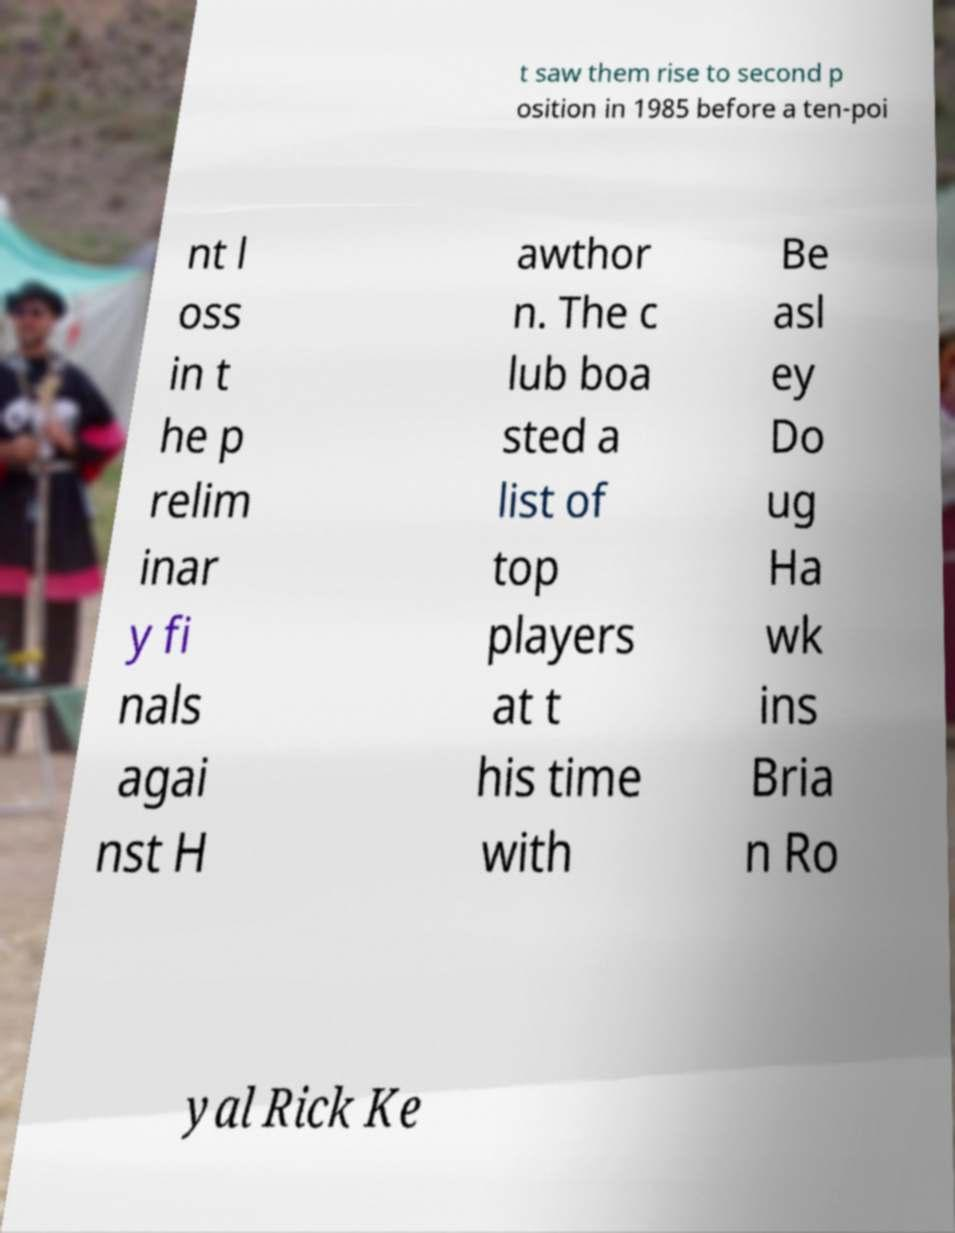There's text embedded in this image that I need extracted. Can you transcribe it verbatim? t saw them rise to second p osition in 1985 before a ten-poi nt l oss in t he p relim inar y fi nals agai nst H awthor n. The c lub boa sted a list of top players at t his time with Be asl ey Do ug Ha wk ins Bria n Ro yal Rick Ke 